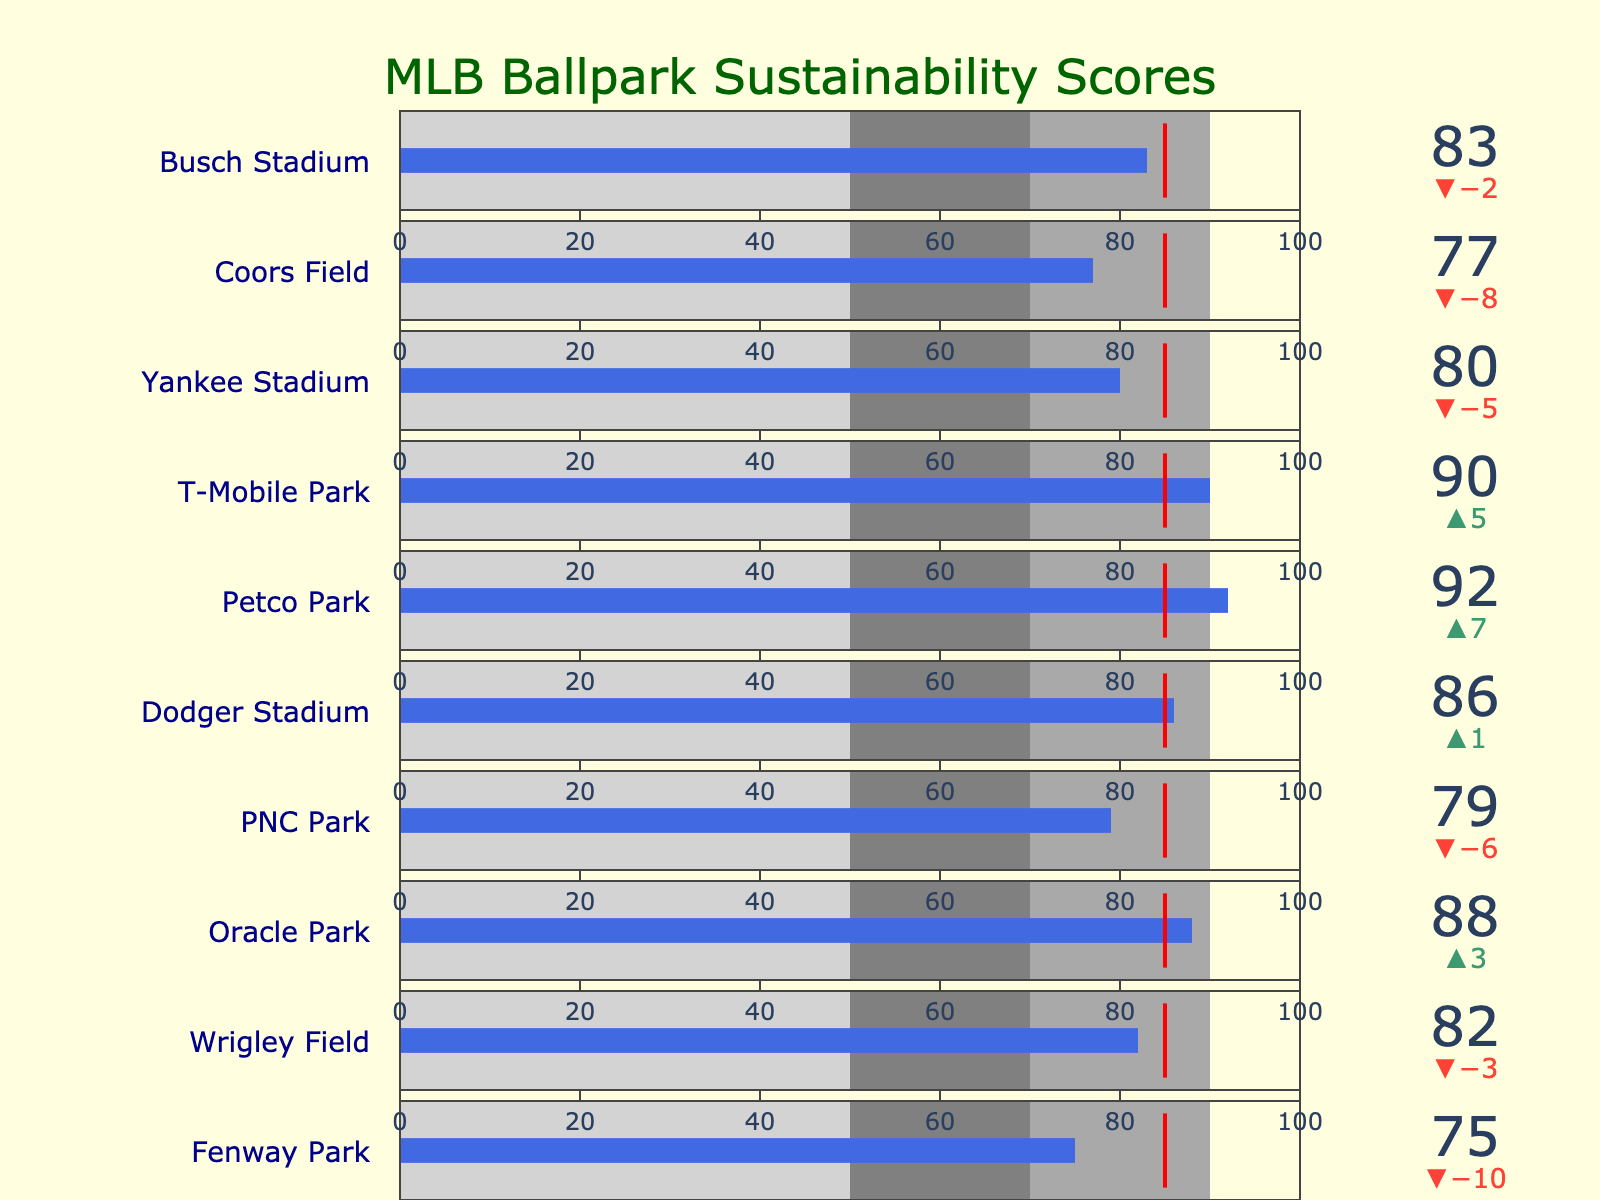What is the title of the chart? The title of the chart is shown at the top of the figure. It reads "MLB Ballpark Sustainability Scores".
Answer: MLB Ballpark Sustainability Scores What color represents the actual sustainability scores in the chart? The actual sustainability scores are represented by royal blue bars within each bullet graphic.
Answer: Royal blue Which stadium has the highest actual sustainability score? By examining the height of the actual score bars in each bullet, Petco Park has the highest score at 92.
Answer: Petco Park How many stadiums meet or exceed the sustainability target? Compare each actual score to the threshold (target). The stadiums that meet or exceed the target (85) are Dodger Stadium, Petco Park, T-Mobile Park, and Oracle Park.
Answer: 4 What is the difference between the actual and target sustainability scores for Fenway Park? Fenway Park's actual score is 75, and the target is 85. The difference is 85 - 75 = 10.
Answer: 10 Which stadium has the lowest sustainability score? By comparing all actual scores, Fenway Park has the lowest score at 75.
Answer: Fenway Park Is Yankee Stadium's sustainability score above the light gray area? The light gray area ranges from 0 to 50. Since Yankee Stadium's score is 80, it is above the light gray area.
Answer: Yes How many stadiums have actual sustainability scores within the gray range (50-70)? By looking at the actual scores, none of the stadiums fall within the range of 50 to 70.
Answer: 0 Which stadium comes closest to the sustainability target without exceeding it? Compare each actual score to the target and find the highest value that is still less than or equal to 85. Yankee Stadium has a score of 80, which is the highest without exceeding the target.
Answer: Yankee Stadium 